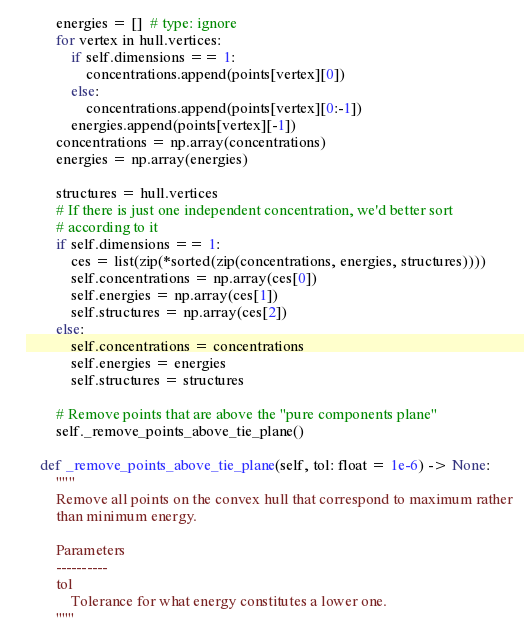Convert code to text. <code><loc_0><loc_0><loc_500><loc_500><_Python_>        energies = []  # type: ignore
        for vertex in hull.vertices:
            if self.dimensions == 1:
                concentrations.append(points[vertex][0])
            else:
                concentrations.append(points[vertex][0:-1])
            energies.append(points[vertex][-1])
        concentrations = np.array(concentrations)
        energies = np.array(energies)

        structures = hull.vertices
        # If there is just one independent concentration, we'd better sort
        # according to it
        if self.dimensions == 1:
            ces = list(zip(*sorted(zip(concentrations, energies, structures))))
            self.concentrations = np.array(ces[0])
            self.energies = np.array(ces[1])
            self.structures = np.array(ces[2])
        else:
            self.concentrations = concentrations
            self.energies = energies
            self.structures = structures

        # Remove points that are above the "pure components plane"
        self._remove_points_above_tie_plane()

    def _remove_points_above_tie_plane(self, tol: float = 1e-6) -> None:
        """
        Remove all points on the convex hull that correspond to maximum rather
        than minimum energy.

        Parameters
        ----------
        tol
            Tolerance for what energy constitutes a lower one.
        """
</code> 